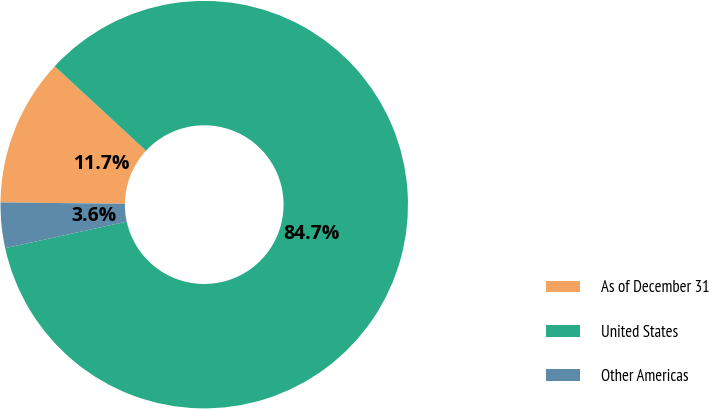<chart> <loc_0><loc_0><loc_500><loc_500><pie_chart><fcel>As of December 31<fcel>United States<fcel>Other Americas<nl><fcel>11.71%<fcel>84.7%<fcel>3.6%<nl></chart> 